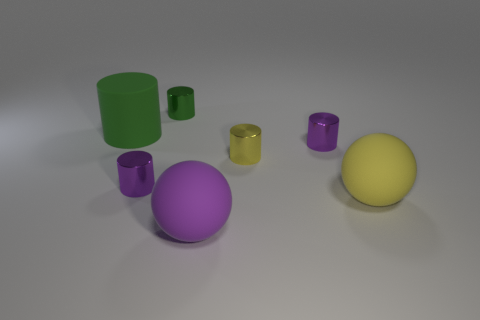Subtract all yellow cylinders. How many cylinders are left? 4 Subtract all yellow cylinders. How many cylinders are left? 4 Subtract all cyan cylinders. Subtract all purple spheres. How many cylinders are left? 5 Add 1 large green shiny cubes. How many objects exist? 8 Subtract all cylinders. How many objects are left? 2 Add 6 tiny green metal things. How many tiny green metal things exist? 7 Subtract 0 green cubes. How many objects are left? 7 Subtract all large purple matte objects. Subtract all big purple things. How many objects are left? 5 Add 6 yellow cylinders. How many yellow cylinders are left? 7 